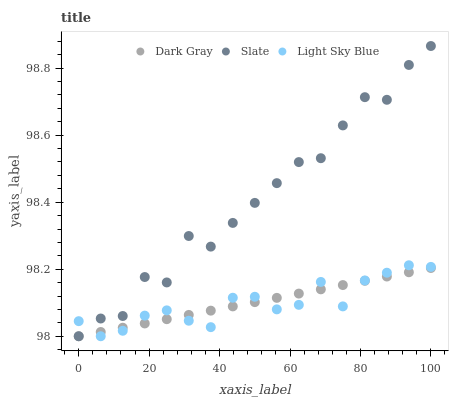Does Light Sky Blue have the minimum area under the curve?
Answer yes or no. Yes. Does Slate have the maximum area under the curve?
Answer yes or no. Yes. Does Slate have the minimum area under the curve?
Answer yes or no. No. Does Light Sky Blue have the maximum area under the curve?
Answer yes or no. No. Is Dark Gray the smoothest?
Answer yes or no. Yes. Is Slate the roughest?
Answer yes or no. Yes. Is Light Sky Blue the smoothest?
Answer yes or no. No. Is Light Sky Blue the roughest?
Answer yes or no. No. Does Dark Gray have the lowest value?
Answer yes or no. Yes. Does Slate have the highest value?
Answer yes or no. Yes. Does Light Sky Blue have the highest value?
Answer yes or no. No. Does Slate intersect Dark Gray?
Answer yes or no. Yes. Is Slate less than Dark Gray?
Answer yes or no. No. Is Slate greater than Dark Gray?
Answer yes or no. No. 